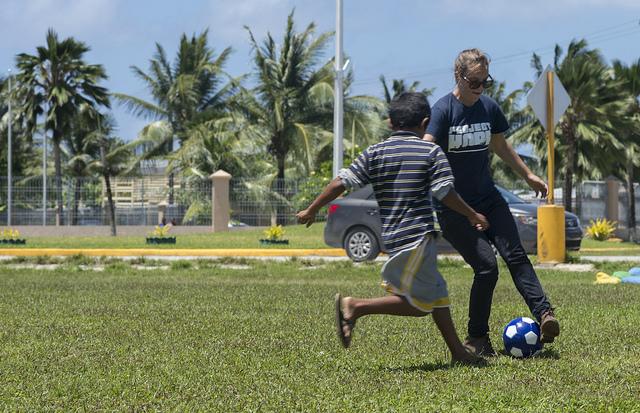How many people are in the grass?
Give a very brief answer. 2. What are they playing?
Quick response, please. Soccer. Anyone women playing?
Give a very brief answer. Yes. 